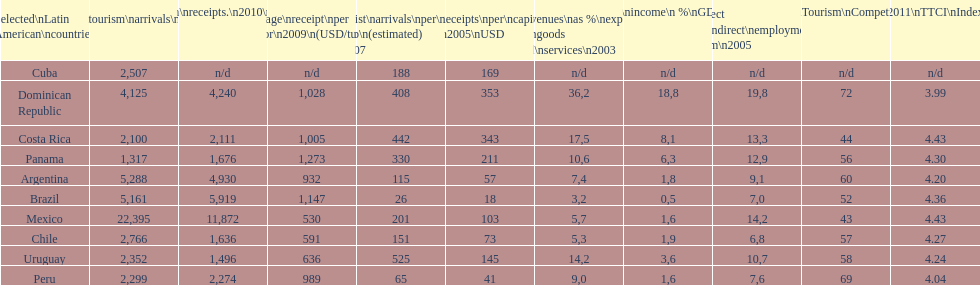How many dollars on average did brazil receive per tourist in 2009? 1,147. 